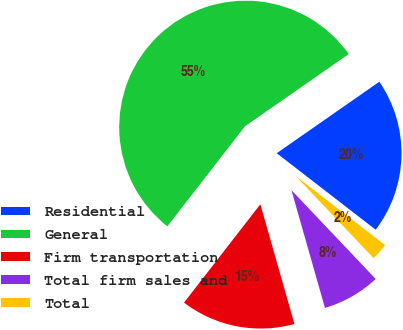Convert chart to OTSL. <chart><loc_0><loc_0><loc_500><loc_500><pie_chart><fcel>Residential<fcel>General<fcel>Firm transportation<fcel>Total firm sales and<fcel>Total<nl><fcel>20.16%<fcel>54.81%<fcel>14.92%<fcel>7.67%<fcel>2.44%<nl></chart> 